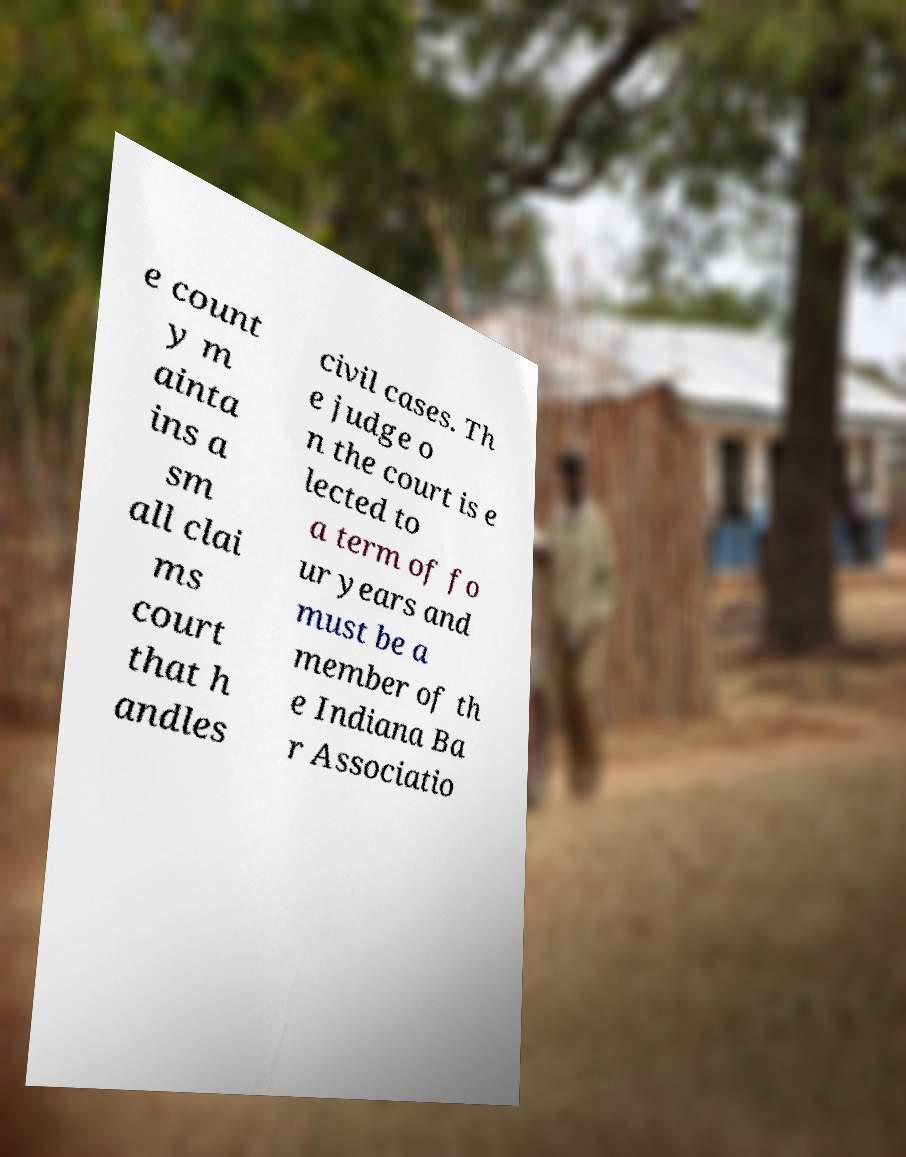What messages or text are displayed in this image? I need them in a readable, typed format. e count y m ainta ins a sm all clai ms court that h andles civil cases. Th e judge o n the court is e lected to a term of fo ur years and must be a member of th e Indiana Ba r Associatio 